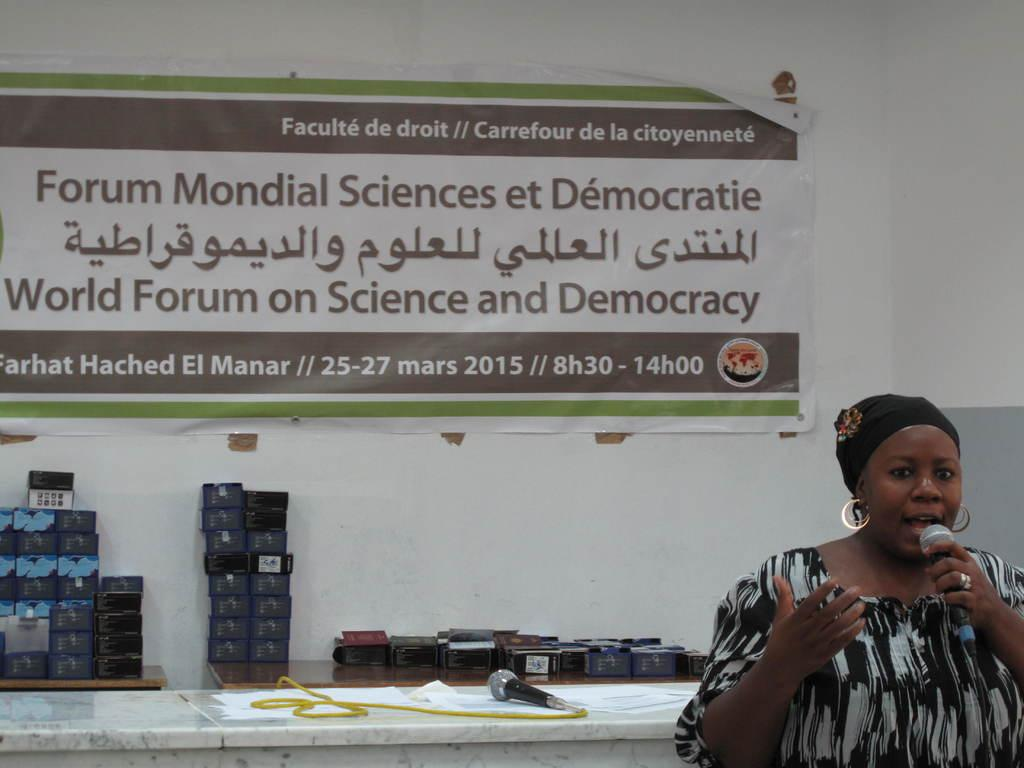What is: Who is the main subject in the image? There is a woman in the image. What is the woman holding in the image? The woman is holding a mic. What can be seen in the background of the image? There are tables, additional mics, boxes, a wall, a banner, and other objects in the background of the image. How many oranges are being used as a substitute for the mics in the image? There are no oranges present in the image, and they are not being used as a substitute for the mics. 